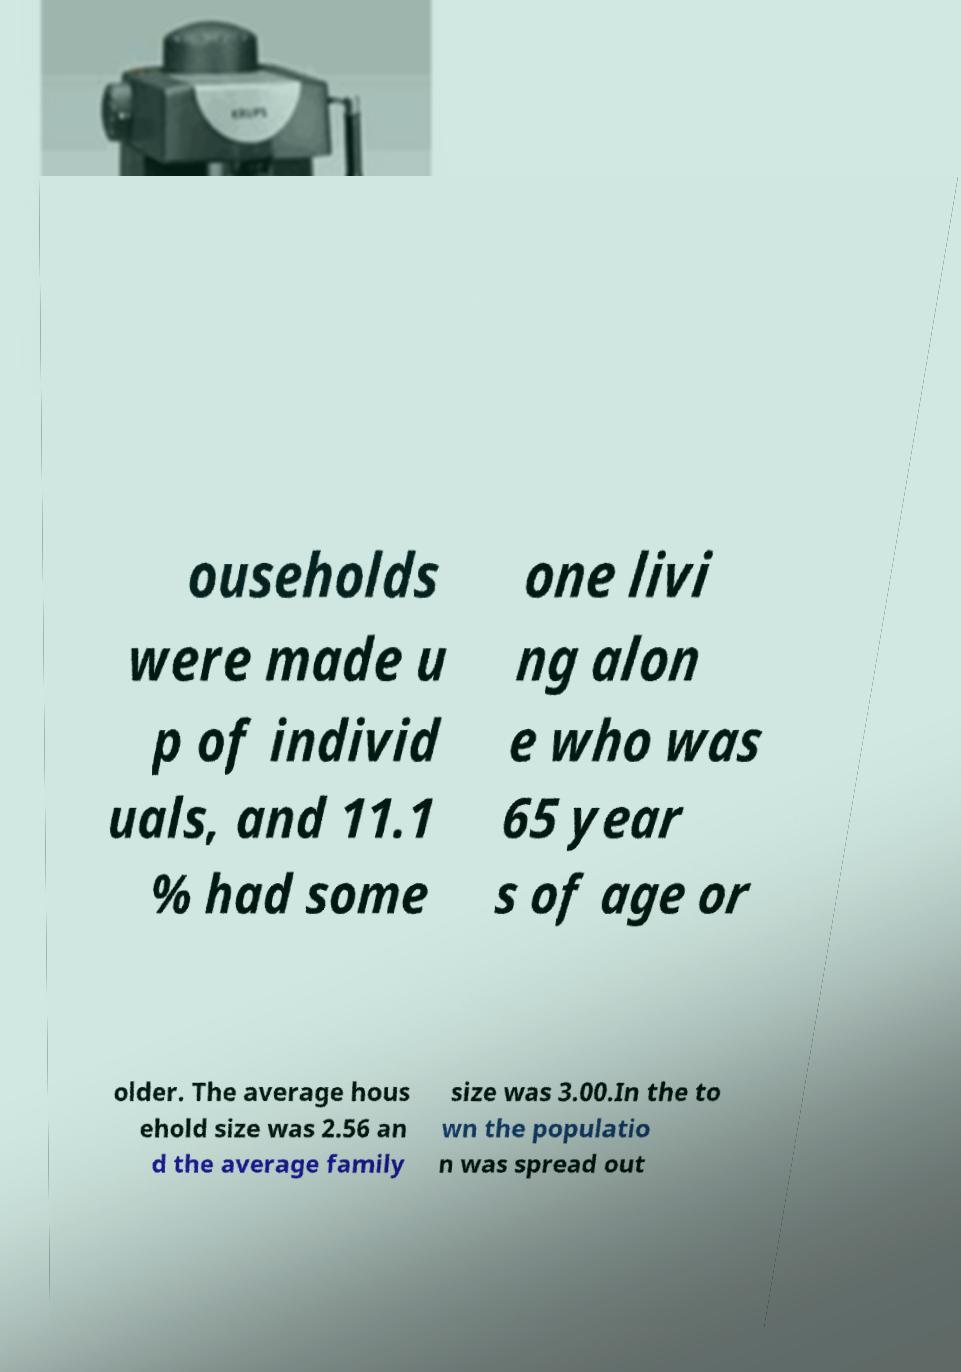Please read and relay the text visible in this image. What does it say? ouseholds were made u p of individ uals, and 11.1 % had some one livi ng alon e who was 65 year s of age or older. The average hous ehold size was 2.56 an d the average family size was 3.00.In the to wn the populatio n was spread out 